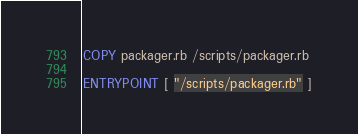Convert code to text. <code><loc_0><loc_0><loc_500><loc_500><_Dockerfile_>COPY packager.rb /scripts/packager.rb

ENTRYPOINT [ "/scripts/packager.rb" ]
</code> 